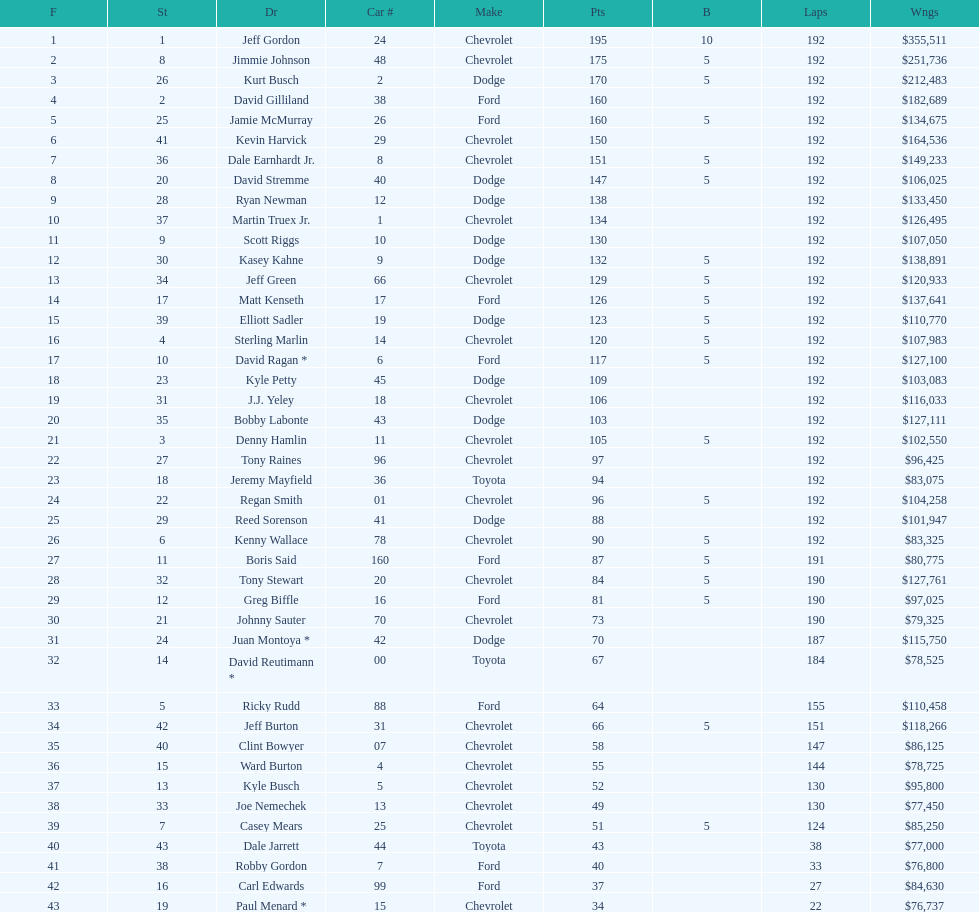What was jimmie johnson's winnings? $251,736. 